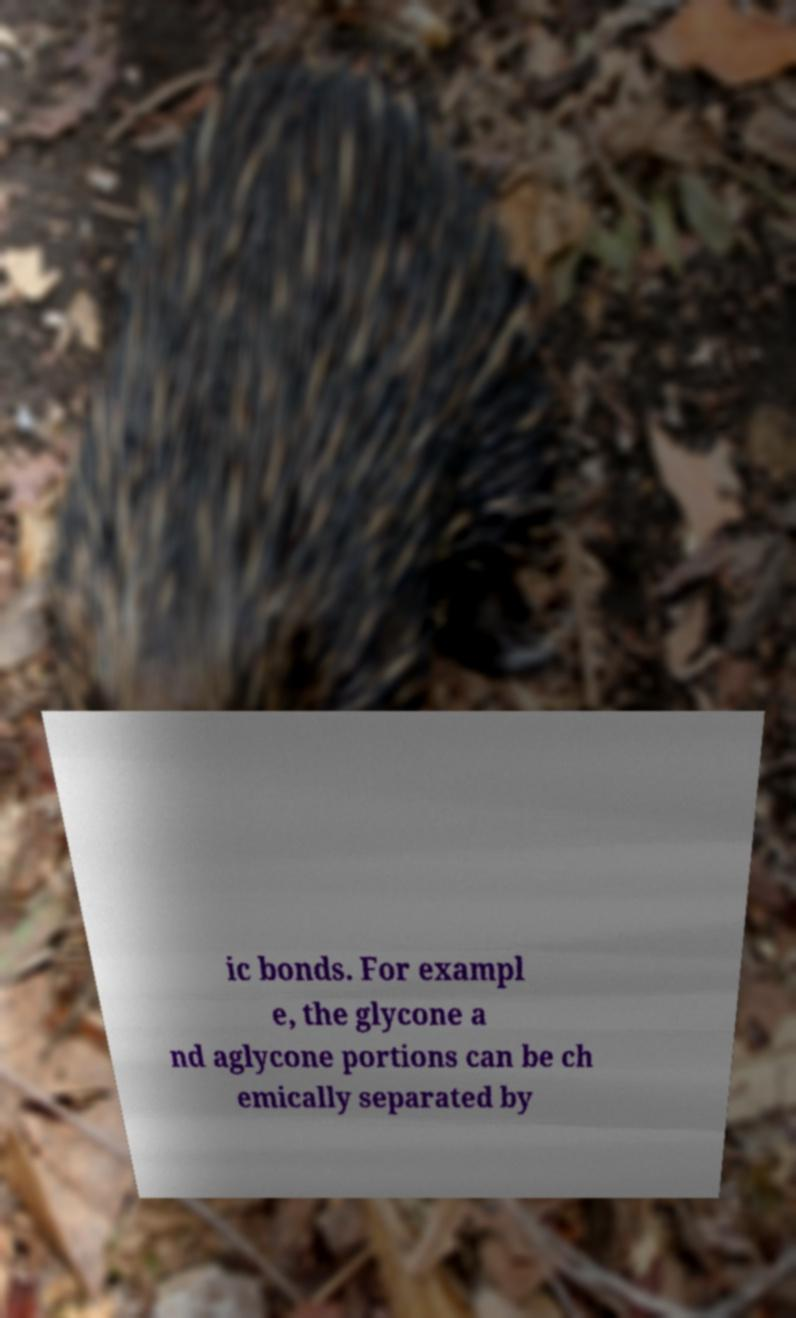I need the written content from this picture converted into text. Can you do that? ic bonds. For exampl e, the glycone a nd aglycone portions can be ch emically separated by 